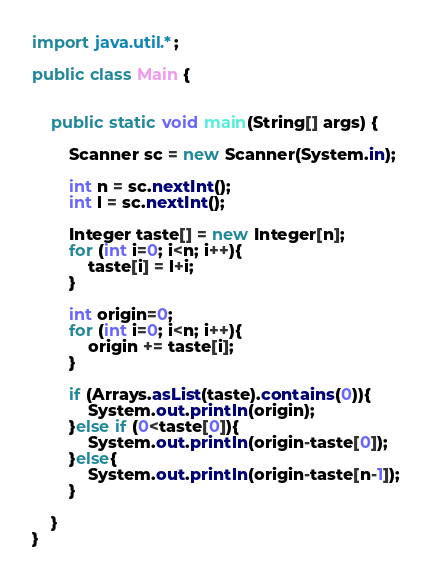Convert code to text. <code><loc_0><loc_0><loc_500><loc_500><_Java_>import java.util.*;

public class Main {


    public static void main(String[] args) {

        Scanner sc = new Scanner(System.in);

        int n = sc.nextInt();
        int l = sc.nextInt();

        Integer taste[] = new Integer[n];
        for (int i=0; i<n; i++){
            taste[i] = l+i;
        }

        int origin=0;
        for (int i=0; i<n; i++){
            origin += taste[i];
        }

        if (Arrays.asList(taste).contains(0)){
            System.out.println(origin);
        }else if (0<taste[0]){
            System.out.println(origin-taste[0]);
        }else{
            System.out.println(origin-taste[n-1]);
        }

    }
}

</code> 